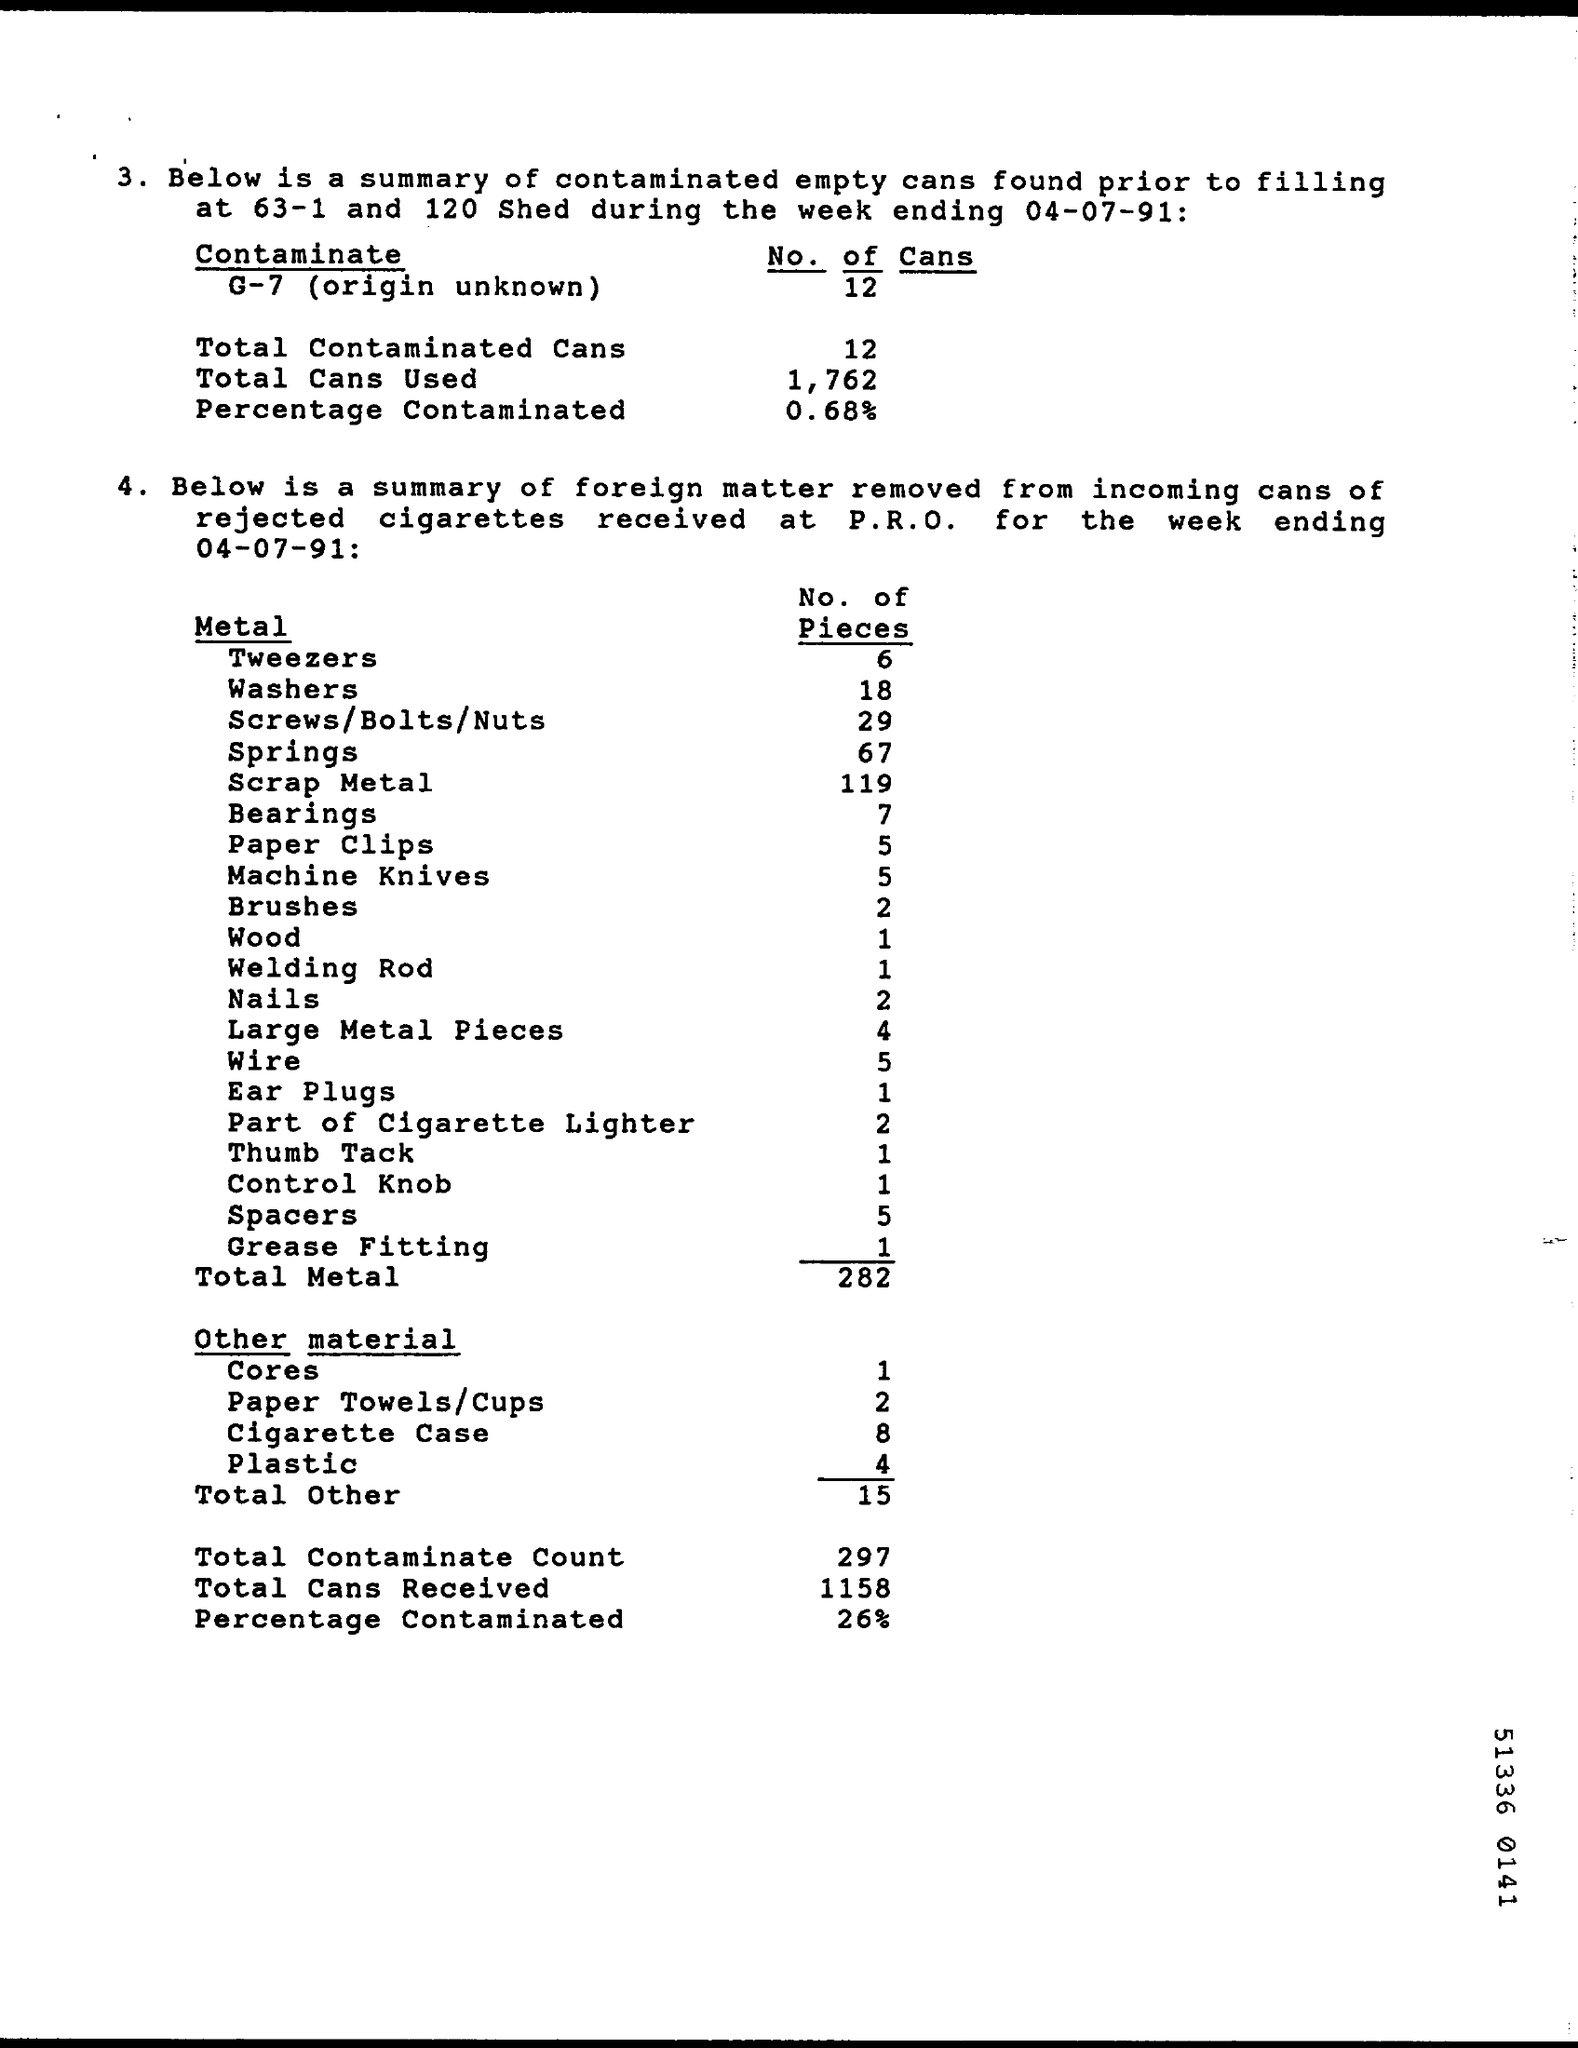How many Cans are used ?
Offer a very short reply. 1,762. How many Pieces are included in the Wood?
Provide a short and direct response. 1. How much Total of Other Material ?
Offer a very short reply. 15. How many Cans  are Received ?
Make the answer very short. 1158. How many Pieces in Plastic ?
Your response must be concise. 4. What is the Count of Total Metal ?
Your answer should be very brief. 282. 